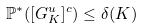<formula> <loc_0><loc_0><loc_500><loc_500>\mathbb { P } ^ { \ast } ( [ G _ { K } ^ { u } ] ^ { c } ) \leq \delta ( K )</formula> 